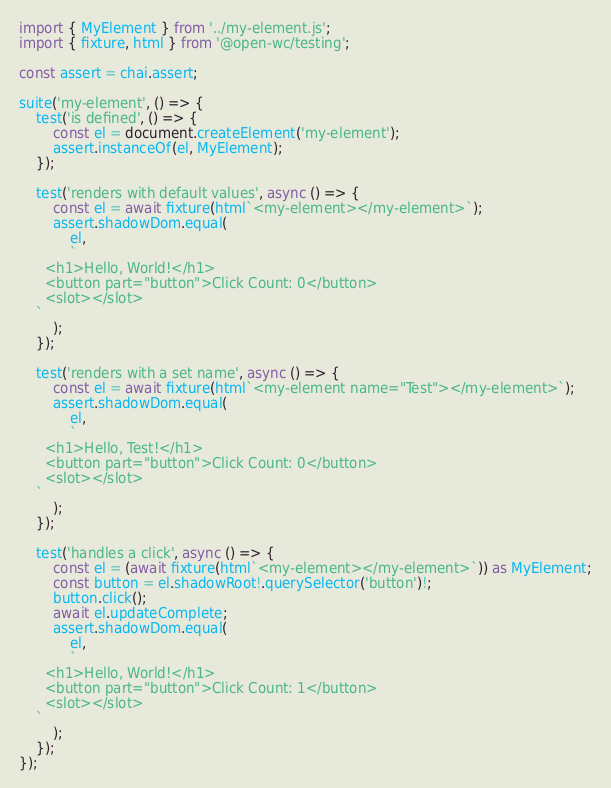<code> <loc_0><loc_0><loc_500><loc_500><_TypeScript_>import { MyElement } from '../my-element.js';
import { fixture, html } from '@open-wc/testing';

const assert = chai.assert;

suite('my-element', () => {
    test('is defined', () => {
        const el = document.createElement('my-element');
        assert.instanceOf(el, MyElement);
    });

    test('renders with default values', async () => {
        const el = await fixture(html`<my-element></my-element>`);
        assert.shadowDom.equal(
            el,
            `
      <h1>Hello, World!</h1>
      <button part="button">Click Count: 0</button>
      <slot></slot>
    `
        );
    });

    test('renders with a set name', async () => {
        const el = await fixture(html`<my-element name="Test"></my-element>`);
        assert.shadowDom.equal(
            el,
            `
      <h1>Hello, Test!</h1>
      <button part="button">Click Count: 0</button>
      <slot></slot>
    `
        );
    });

    test('handles a click', async () => {
        const el = (await fixture(html`<my-element></my-element>`)) as MyElement;
        const button = el.shadowRoot!.querySelector('button')!;
        button.click();
        await el.updateComplete;
        assert.shadowDom.equal(
            el,
            `
      <h1>Hello, World!</h1>
      <button part="button">Click Count: 1</button>
      <slot></slot>
    `
        );
    });
});
</code> 